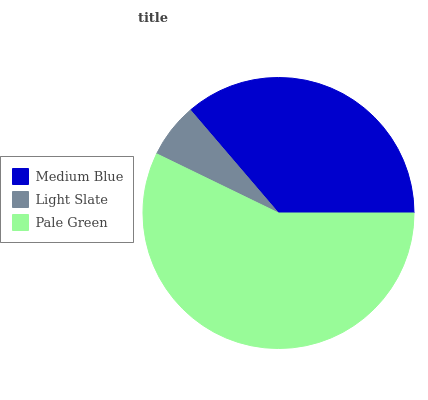Is Light Slate the minimum?
Answer yes or no. Yes. Is Pale Green the maximum?
Answer yes or no. Yes. Is Pale Green the minimum?
Answer yes or no. No. Is Light Slate the maximum?
Answer yes or no. No. Is Pale Green greater than Light Slate?
Answer yes or no. Yes. Is Light Slate less than Pale Green?
Answer yes or no. Yes. Is Light Slate greater than Pale Green?
Answer yes or no. No. Is Pale Green less than Light Slate?
Answer yes or no. No. Is Medium Blue the high median?
Answer yes or no. Yes. Is Medium Blue the low median?
Answer yes or no. Yes. Is Pale Green the high median?
Answer yes or no. No. Is Pale Green the low median?
Answer yes or no. No. 